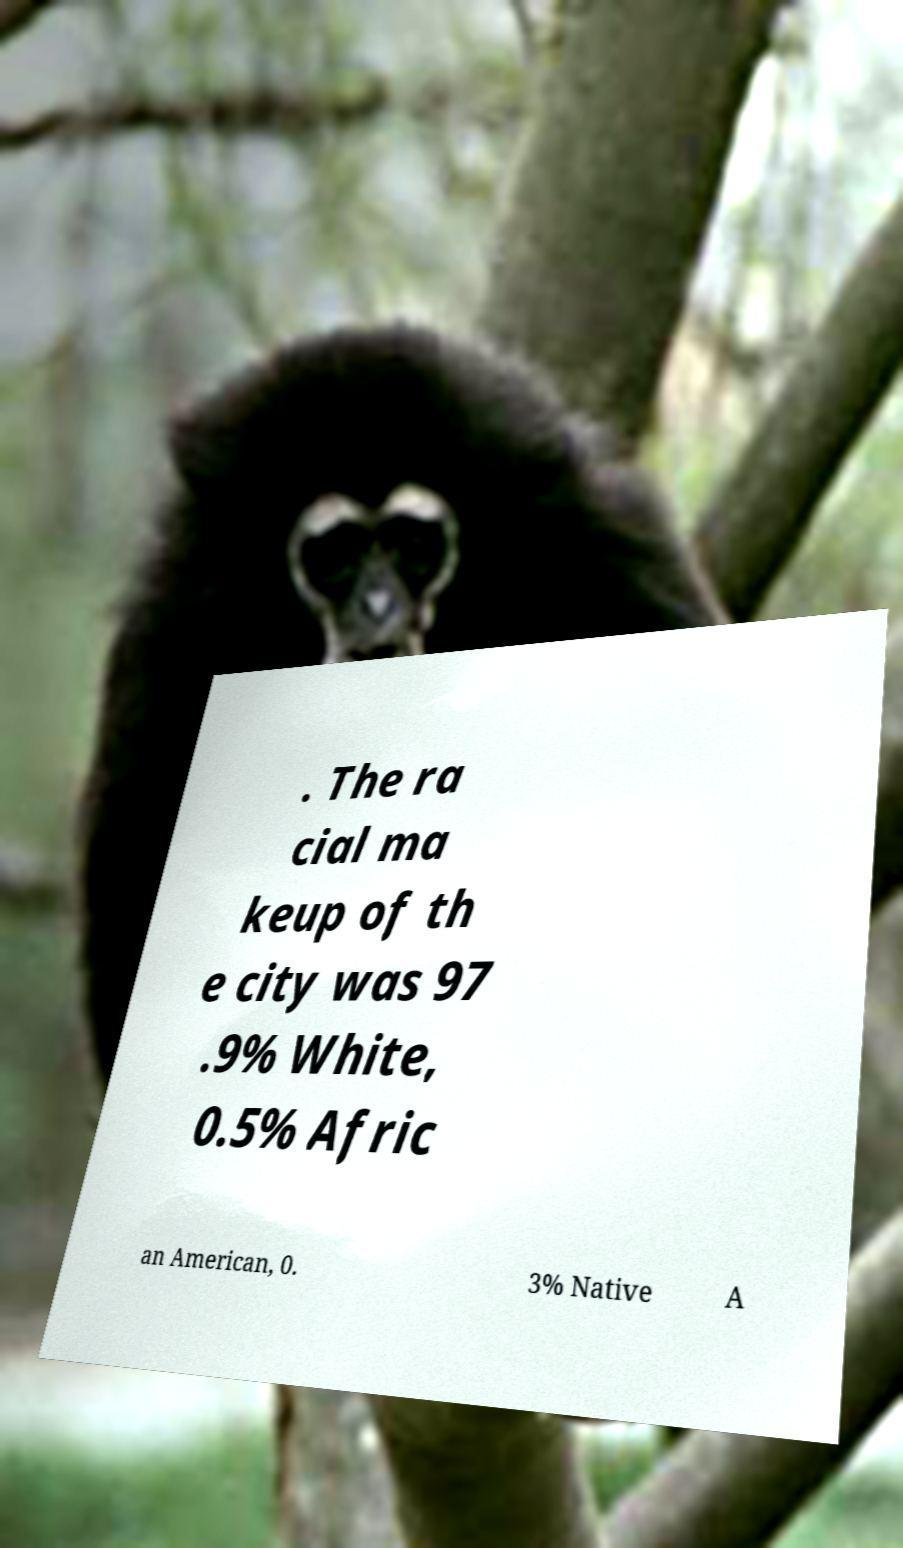Can you accurately transcribe the text from the provided image for me? . The ra cial ma keup of th e city was 97 .9% White, 0.5% Afric an American, 0. 3% Native A 